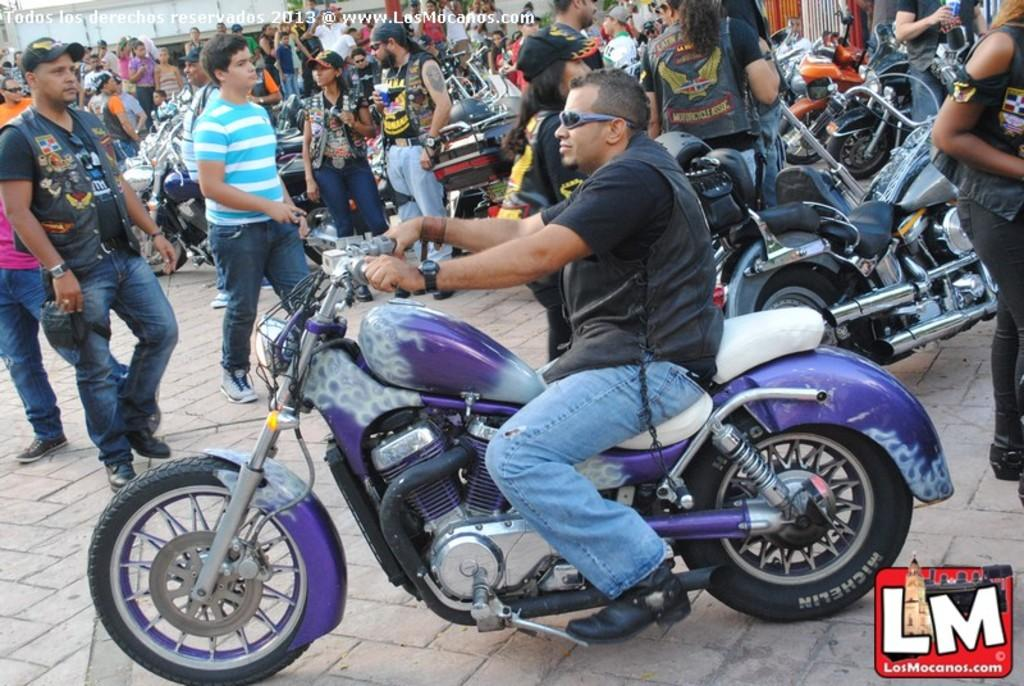What is happening in the image involving a group of people? There is a group of people in the image, and some of them are riding a bicycle, walking, and standing. Can you describe the activity of one person in the image? Yes, a man is riding a bicycle in the image. What are some of the other people in the image doing? Some people are walking, and some are standing. What type of rule does the kitten have in the image? There is no kitten present in the image, so it is not possible to determine if there is a rule or what type of rule it might have. 